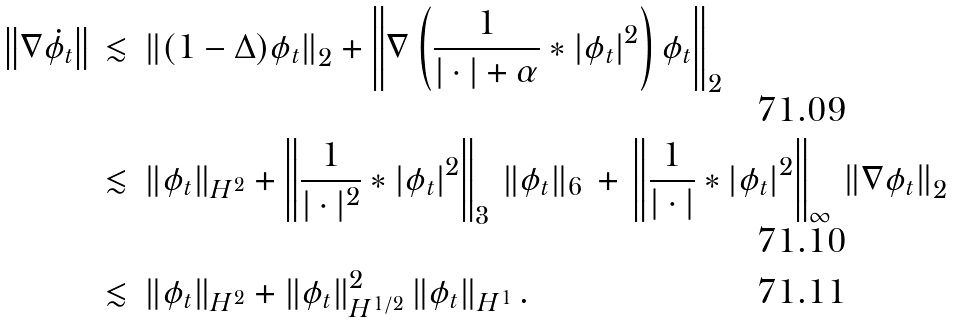Convert formula to latex. <formula><loc_0><loc_0><loc_500><loc_500>\left \| \nabla \dot { \phi } _ { t } \right \| \, & \lesssim \, \left \| ( 1 - \Delta ) \phi _ { t } \right \| _ { 2 } + \left \| \nabla \left ( \frac { 1 } { | \cdot | + \alpha } * | \phi _ { t } | ^ { 2 } \right ) \phi _ { t } \right \| _ { 2 } \\ & \lesssim \, \| \phi _ { t } \| _ { H ^ { 2 } } + \left \| \frac { 1 } { | \cdot | ^ { 2 } } * | \phi _ { t } | ^ { 2 } \right \| _ { 3 } \, \| \phi _ { t } \| _ { 6 } \, + \, \left \| \frac { 1 } { | \cdot | } * | \phi _ { t } | ^ { 2 } \right \| _ { \infty } \, \left \| \nabla \phi _ { t } \right \| _ { 2 } \\ & \lesssim \, \| \phi _ { t } \| _ { H ^ { 2 } } + \| \phi _ { t } \| _ { H ^ { 1 / 2 } } ^ { 2 } \, \| \phi _ { t } \| _ { H ^ { 1 } } \, .</formula> 